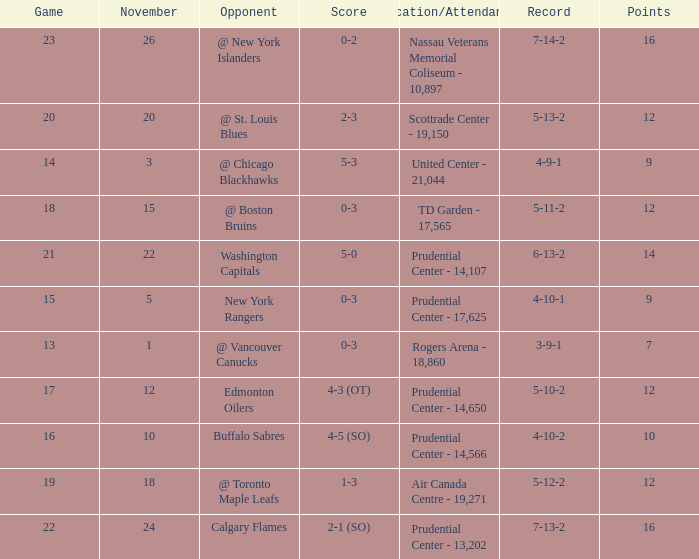Would you mind parsing the complete table? {'header': ['Game', 'November', 'Opponent', 'Score', 'Location/Attendance', 'Record', 'Points'], 'rows': [['23', '26', '@ New York Islanders', '0-2', 'Nassau Veterans Memorial Coliseum - 10,897', '7-14-2', '16'], ['20', '20', '@ St. Louis Blues', '2-3', 'Scottrade Center - 19,150', '5-13-2', '12'], ['14', '3', '@ Chicago Blackhawks', '5-3', 'United Center - 21,044', '4-9-1', '9'], ['18', '15', '@ Boston Bruins', '0-3', 'TD Garden - 17,565', '5-11-2', '12'], ['21', '22', 'Washington Capitals', '5-0', 'Prudential Center - 14,107', '6-13-2', '14'], ['15', '5', 'New York Rangers', '0-3', 'Prudential Center - 17,625', '4-10-1', '9'], ['13', '1', '@ Vancouver Canucks', '0-3', 'Rogers Arena - 18,860', '3-9-1', '7'], ['17', '12', 'Edmonton Oilers', '4-3 (OT)', 'Prudential Center - 14,650', '5-10-2', '12'], ['16', '10', 'Buffalo Sabres', '4-5 (SO)', 'Prudential Center - 14,566', '4-10-2', '10'], ['19', '18', '@ Toronto Maple Leafs', '1-3', 'Air Canada Centre - 19,271', '5-12-2', '12'], ['22', '24', 'Calgary Flames', '2-1 (SO)', 'Prudential Center - 13,202', '7-13-2', '16']]} What is the record for score 1-3? 5-12-2. 